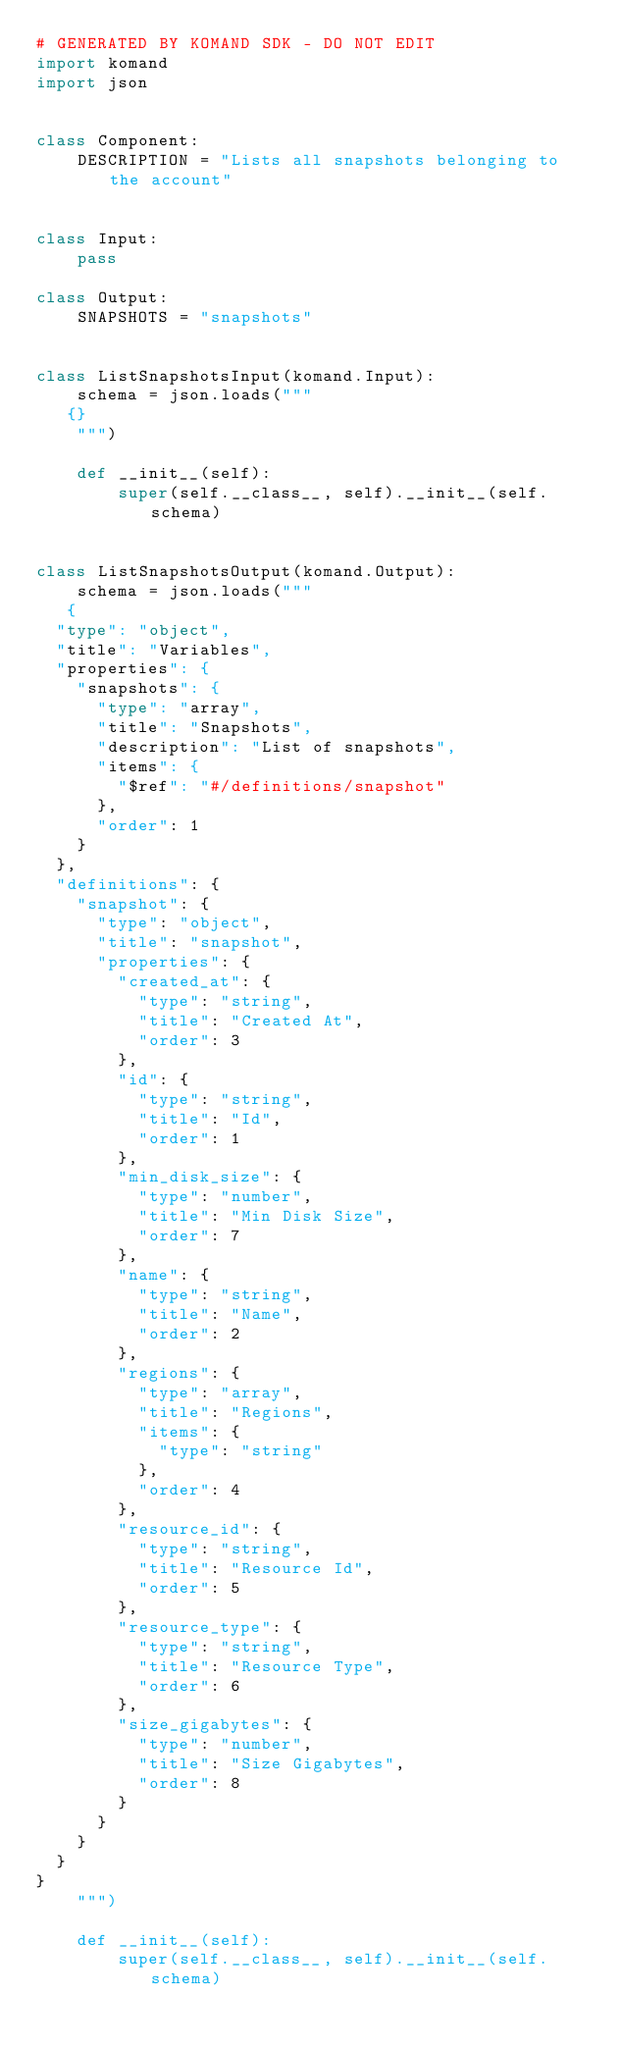<code> <loc_0><loc_0><loc_500><loc_500><_Python_># GENERATED BY KOMAND SDK - DO NOT EDIT
import komand
import json


class Component:
    DESCRIPTION = "Lists all snapshots belonging to the account"


class Input:
    pass

class Output:
    SNAPSHOTS = "snapshots"
    

class ListSnapshotsInput(komand.Input):
    schema = json.loads("""
   {}
    """)

    def __init__(self):
        super(self.__class__, self).__init__(self.schema)


class ListSnapshotsOutput(komand.Output):
    schema = json.loads("""
   {
  "type": "object",
  "title": "Variables",
  "properties": {
    "snapshots": {
      "type": "array",
      "title": "Snapshots",
      "description": "List of snapshots",
      "items": {
        "$ref": "#/definitions/snapshot"
      },
      "order": 1
    }
  },
  "definitions": {
    "snapshot": {
      "type": "object",
      "title": "snapshot",
      "properties": {
        "created_at": {
          "type": "string",
          "title": "Created At",
          "order": 3
        },
        "id": {
          "type": "string",
          "title": "Id",
          "order": 1
        },
        "min_disk_size": {
          "type": "number",
          "title": "Min Disk Size",
          "order": 7
        },
        "name": {
          "type": "string",
          "title": "Name",
          "order": 2
        },
        "regions": {
          "type": "array",
          "title": "Regions",
          "items": {
            "type": "string"
          },
          "order": 4
        },
        "resource_id": {
          "type": "string",
          "title": "Resource Id",
          "order": 5
        },
        "resource_type": {
          "type": "string",
          "title": "Resource Type",
          "order": 6
        },
        "size_gigabytes": {
          "type": "number",
          "title": "Size Gigabytes",
          "order": 8
        }
      }
    }
  }
}
    """)

    def __init__(self):
        super(self.__class__, self).__init__(self.schema)
</code> 